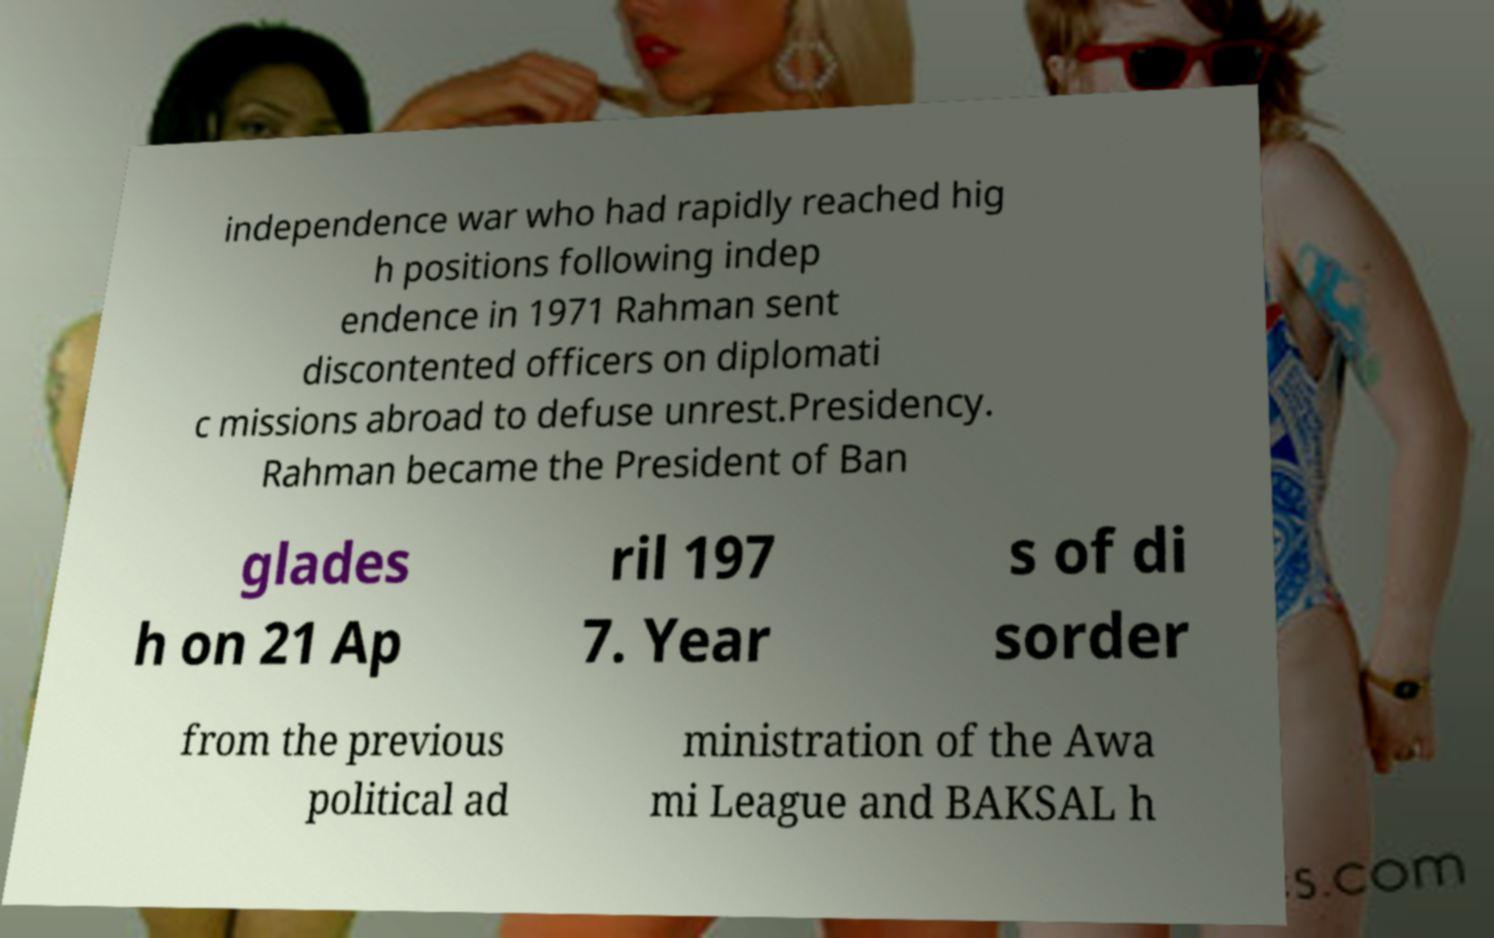Could you assist in decoding the text presented in this image and type it out clearly? independence war who had rapidly reached hig h positions following indep endence in 1971 Rahman sent discontented officers on diplomati c missions abroad to defuse unrest.Presidency. Rahman became the President of Ban glades h on 21 Ap ril 197 7. Year s of di sorder from the previous political ad ministration of the Awa mi League and BAKSAL h 